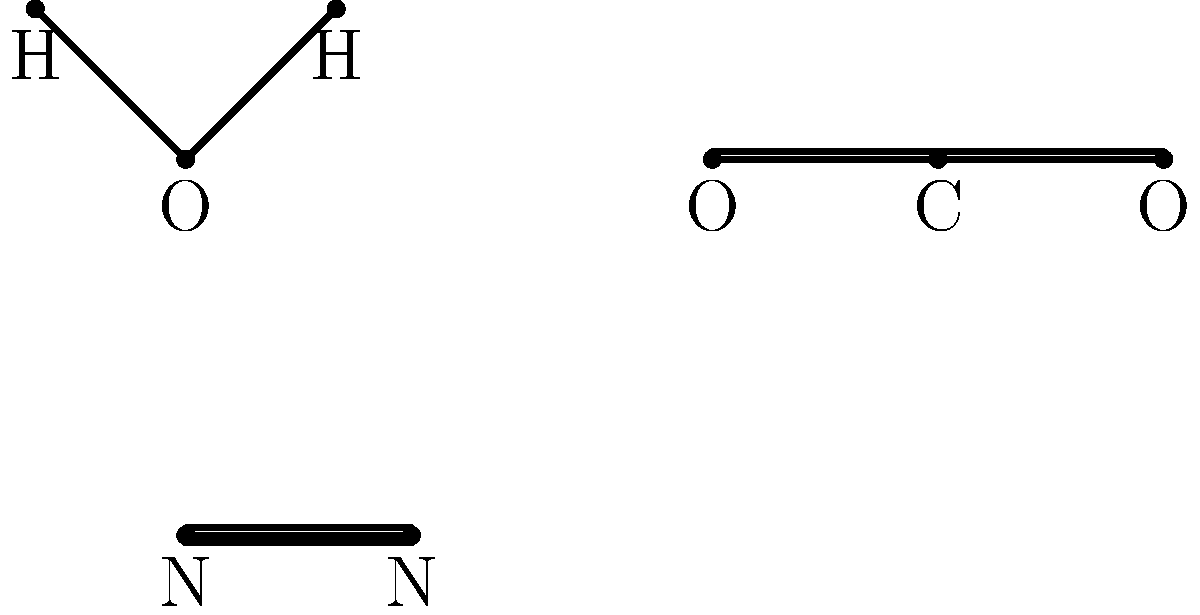Analyze the molecular structure diagrams provided and identify the types of chemical bonds present in each molecule. Which molecule contains a triple bond? To identify the types of chemical bonds and determine which molecule contains a triple bond, let's analyze each molecule step-by-step:

1. Molecule 1 (H2O):
   - This molecule has two single lines connecting the oxygen (O) atom to two hydrogen (H) atoms.
   - Single lines represent single covalent bonds.
   - H2O has two single covalent bonds.

2. Molecule 2 (CO2):
   - This molecule has two double lines connecting the carbon (C) atom to two oxygen (O) atoms.
   - Double lines represent double covalent bonds.
   - CO2 has two double covalent bonds.

3. Molecule 3 (N2):
   - This molecule has three lines connecting two nitrogen (N) atoms.
   - Three lines represent a triple covalent bond.
   - N2 has one triple covalent bond.

By analyzing these molecular structures, we can see that only the N2 molecule contains a triple bond.
Answer: N2 (nitrogen molecule) 